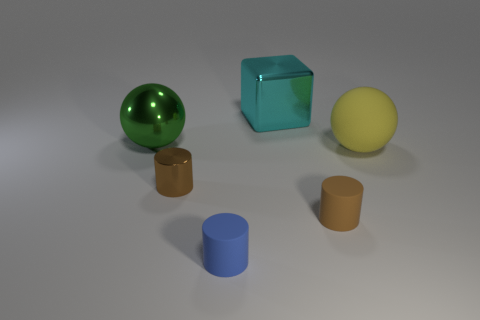How are the shapes distributed across the surface? The shapes are evenly spaced across the surface, which appears to be a flat, neutral-toned plane. The green sphere, turquoise cube, and yellow sphere form a diagonal line from the forefront to the background on the left, while the cylindrical shapes are situated slightly to the right, creating an organized and balanced composition. 